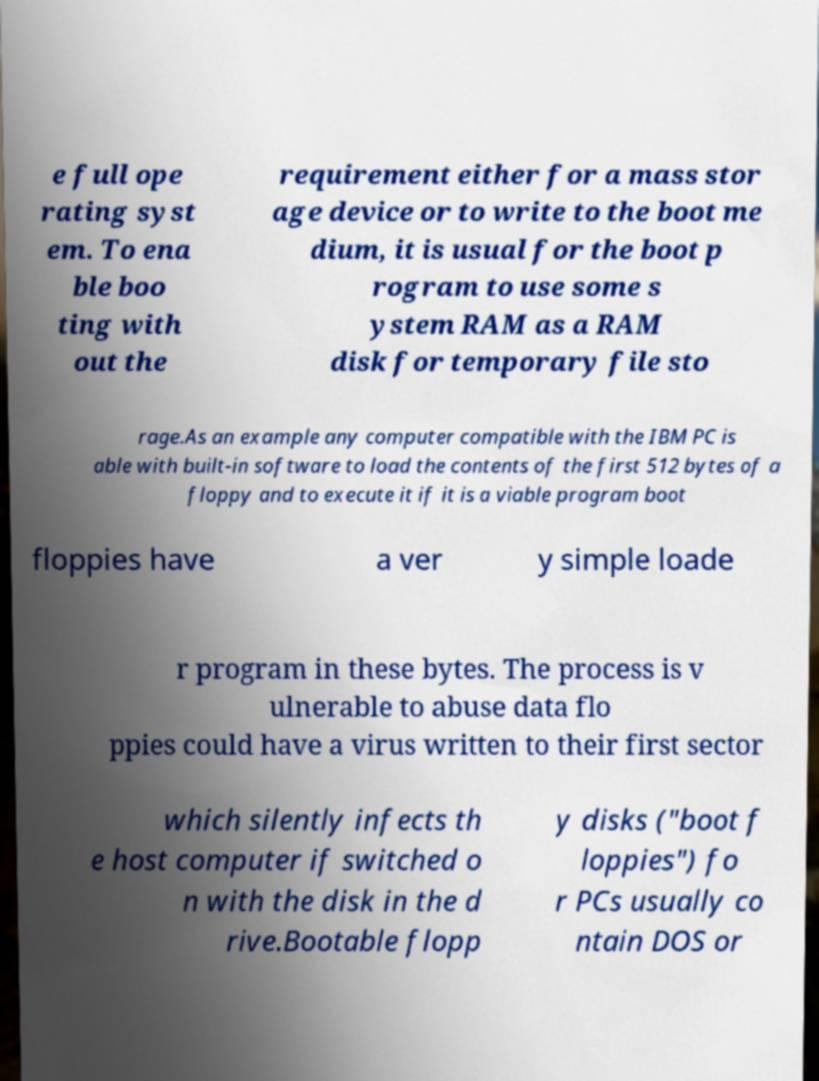I need the written content from this picture converted into text. Can you do that? e full ope rating syst em. To ena ble boo ting with out the requirement either for a mass stor age device or to write to the boot me dium, it is usual for the boot p rogram to use some s ystem RAM as a RAM disk for temporary file sto rage.As an example any computer compatible with the IBM PC is able with built-in software to load the contents of the first 512 bytes of a floppy and to execute it if it is a viable program boot floppies have a ver y simple loade r program in these bytes. The process is v ulnerable to abuse data flo ppies could have a virus written to their first sector which silently infects th e host computer if switched o n with the disk in the d rive.Bootable flopp y disks ("boot f loppies") fo r PCs usually co ntain DOS or 